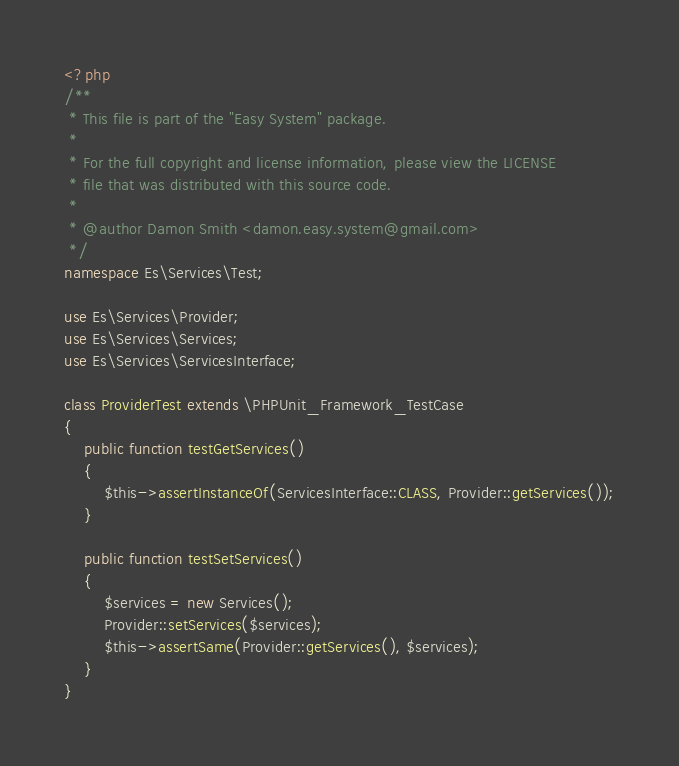<code> <loc_0><loc_0><loc_500><loc_500><_PHP_><?php
/**
 * This file is part of the "Easy System" package.
 *
 * For the full copyright and license information, please view the LICENSE
 * file that was distributed with this source code.
 *
 * @author Damon Smith <damon.easy.system@gmail.com>
 */
namespace Es\Services\Test;

use Es\Services\Provider;
use Es\Services\Services;
use Es\Services\ServicesInterface;

class ProviderTest extends \PHPUnit_Framework_TestCase
{
    public function testGetServices()
    {
        $this->assertInstanceOf(ServicesInterface::CLASS, Provider::getServices());
    }

    public function testSetServices()
    {
        $services = new Services();
        Provider::setServices($services);
        $this->assertSame(Provider::getServices(), $services);
    }
}
</code> 